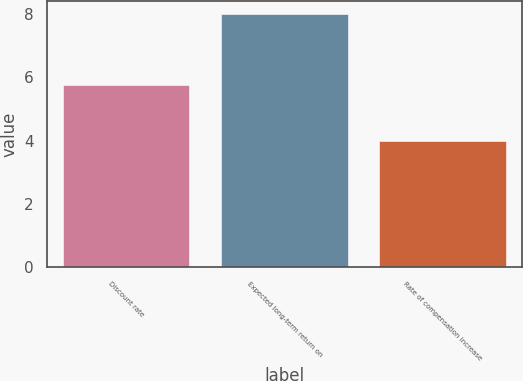<chart> <loc_0><loc_0><loc_500><loc_500><bar_chart><fcel>Discount rate<fcel>Expected long-term return on<fcel>Rate of compensation increase<nl><fcel>5.75<fcel>8<fcel>4<nl></chart> 